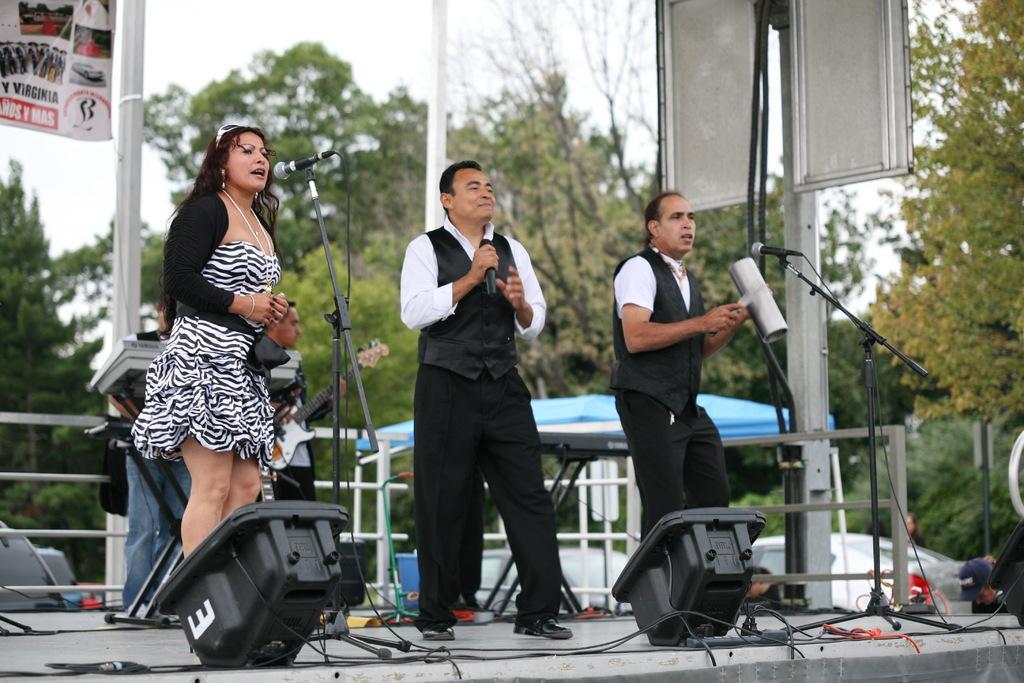Please provide a concise description of this image. In this picture we can see some people standing on stage, wires, guitar, banner, trees, poles, tent and in the background we can see the sky. 